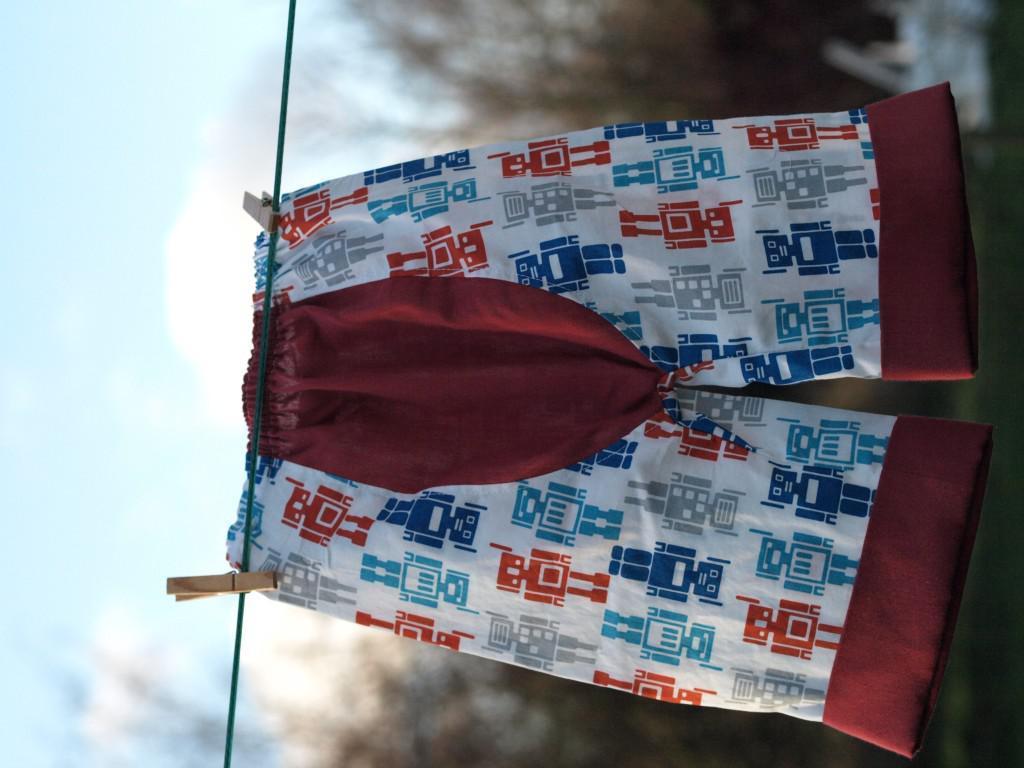Please provide a concise description of this image. This image is in left direction. Here I can see a short which is hanging on a rope. In the background there are many trees. On the left side, I can see the sky. 